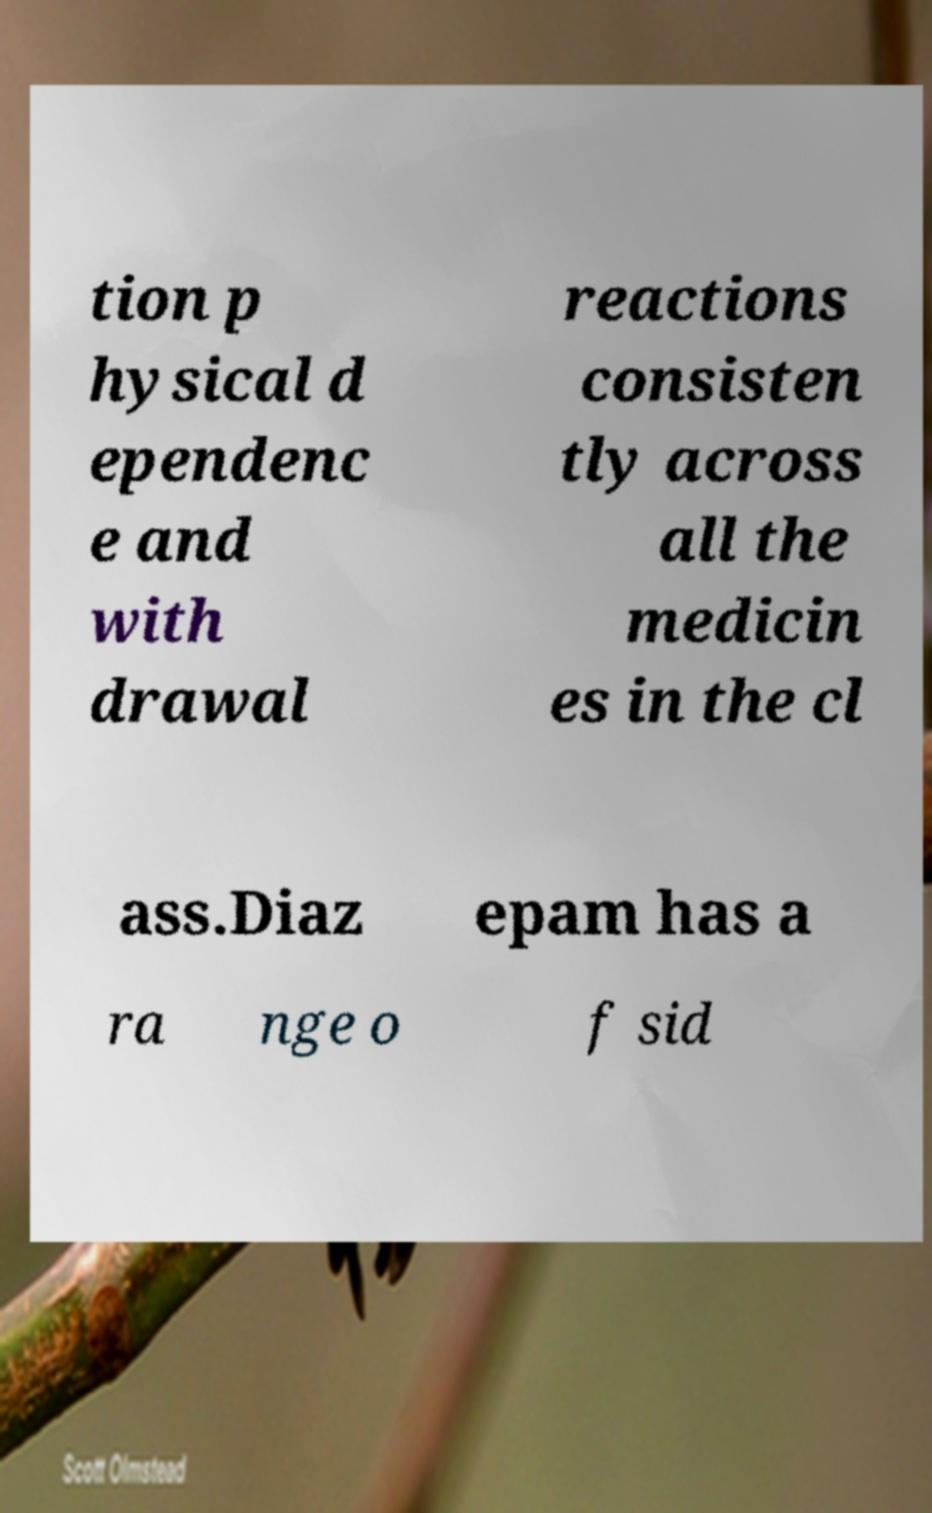There's text embedded in this image that I need extracted. Can you transcribe it verbatim? tion p hysical d ependenc e and with drawal reactions consisten tly across all the medicin es in the cl ass.Diaz epam has a ra nge o f sid 